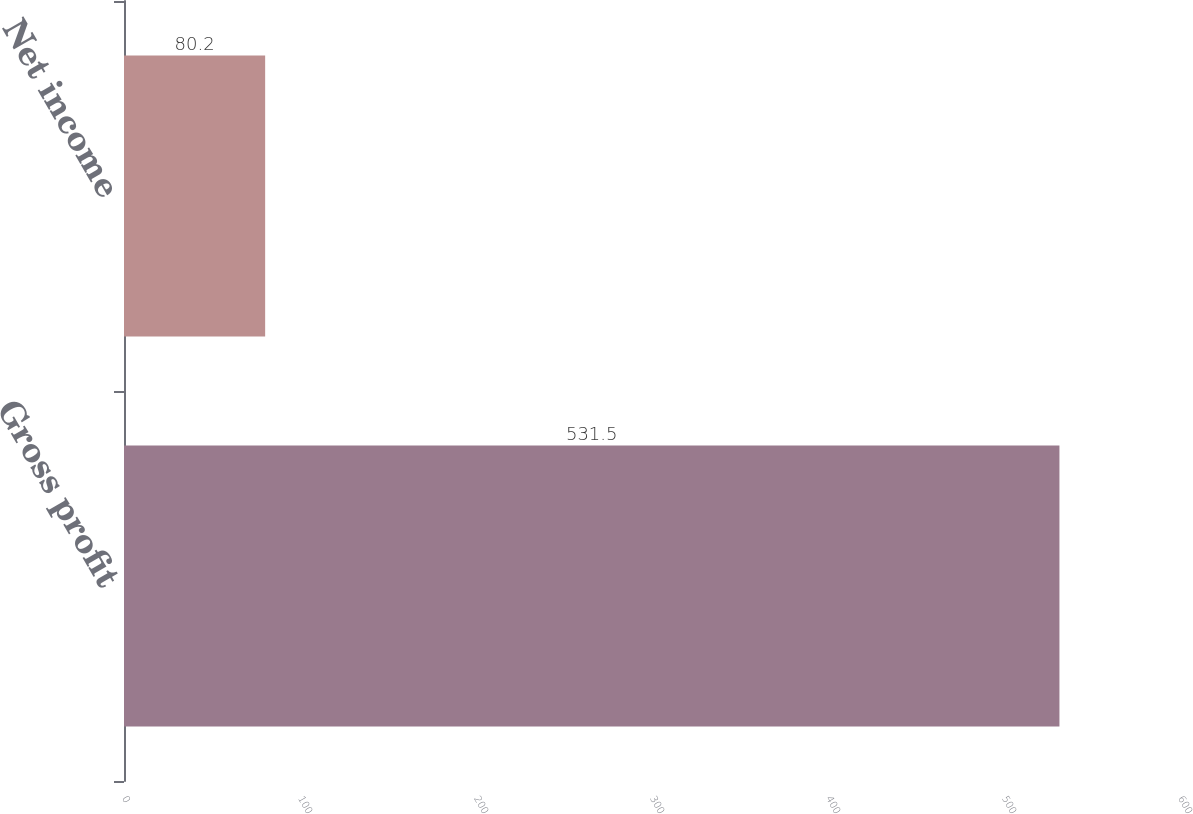Convert chart. <chart><loc_0><loc_0><loc_500><loc_500><bar_chart><fcel>Gross profit<fcel>Net income<nl><fcel>531.5<fcel>80.2<nl></chart> 